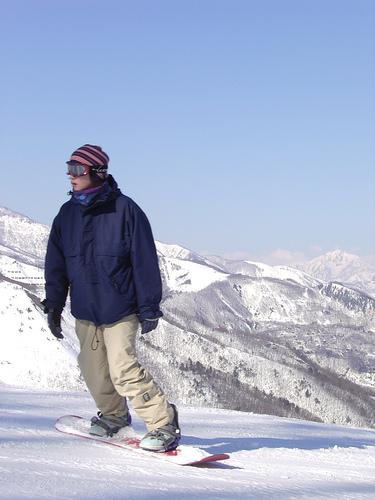What sport are they playing?
Keep it brief. Snowboarding. Is the man a professional skier?
Quick response, please. No. What is cast?
Answer briefly. Shadow. Is this a mountainous picture?
Be succinct. Yes. Is anyone on skis?
Quick response, please. No. What color is his coat?
Write a very short answer. Blue. Why are his arms bare?
Concise answer only. They aren't. What sport is shown?
Quick response, please. Snowboarding. What color is the person's jacket?
Be succinct. Blue. Are the people sitting putting on their snowboards?
Concise answer only. No. What color pants is he wearing?
Short answer required. White. 